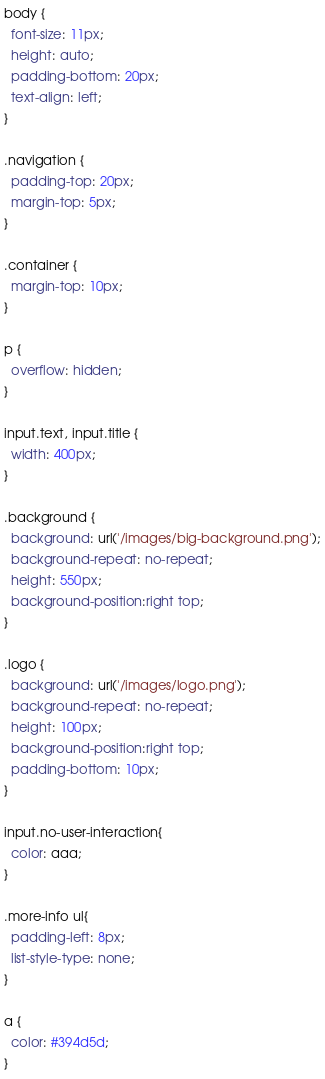<code> <loc_0><loc_0><loc_500><loc_500><_CSS_>body {
  font-size: 11px;
  height: auto;
  padding-bottom: 20px;
  text-align: left;
}

.navigation {
  padding-top: 20px;
  margin-top: 5px;
}

.container {
  margin-top: 10px;
}

p {
  overflow: hidden;
}

input.text, input.title {
  width: 400px;
}

.background {
  background: url('/images/big-background.png');
  background-repeat: no-repeat;
  height: 550px;
  background-position:right top;
}

.logo {
  background: url('/images/logo.png');
  background-repeat: no-repeat;
  height: 100px;
  background-position:right top;
  padding-bottom: 10px;
}

input.no-user-interaction{
  color: aaa;
}

.more-info ul{
  padding-left: 8px;
  list-style-type: none;
}

a {
  color: #394d5d;
}
</code> 